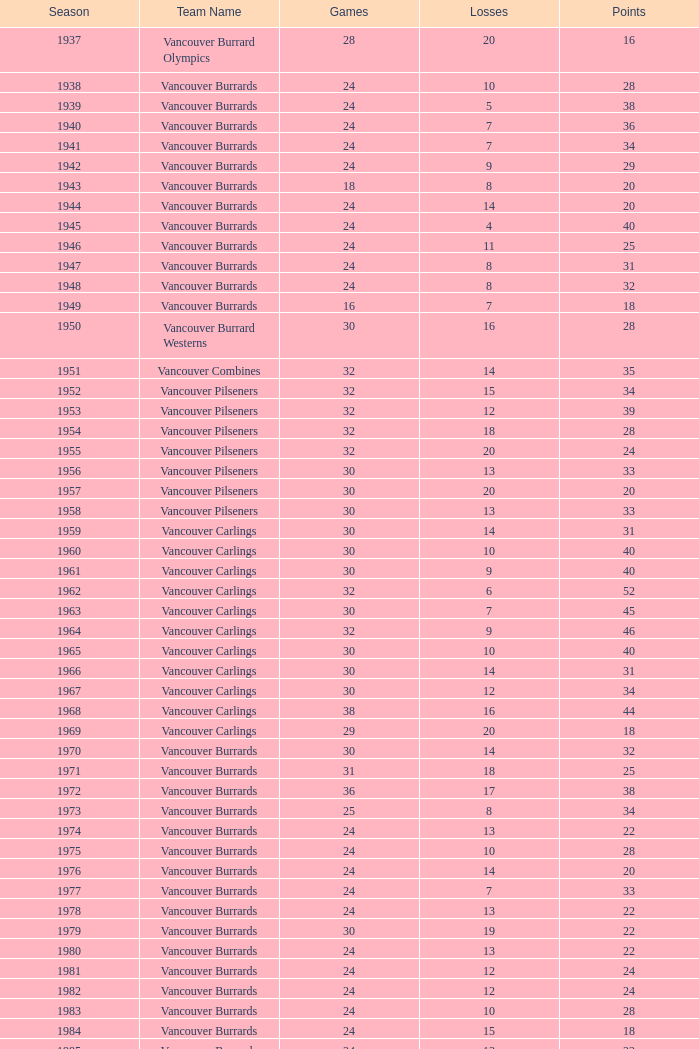What's the total number of points when the vancouver burrards have fewer than 9 losses and more than 24 games? 1.0. 